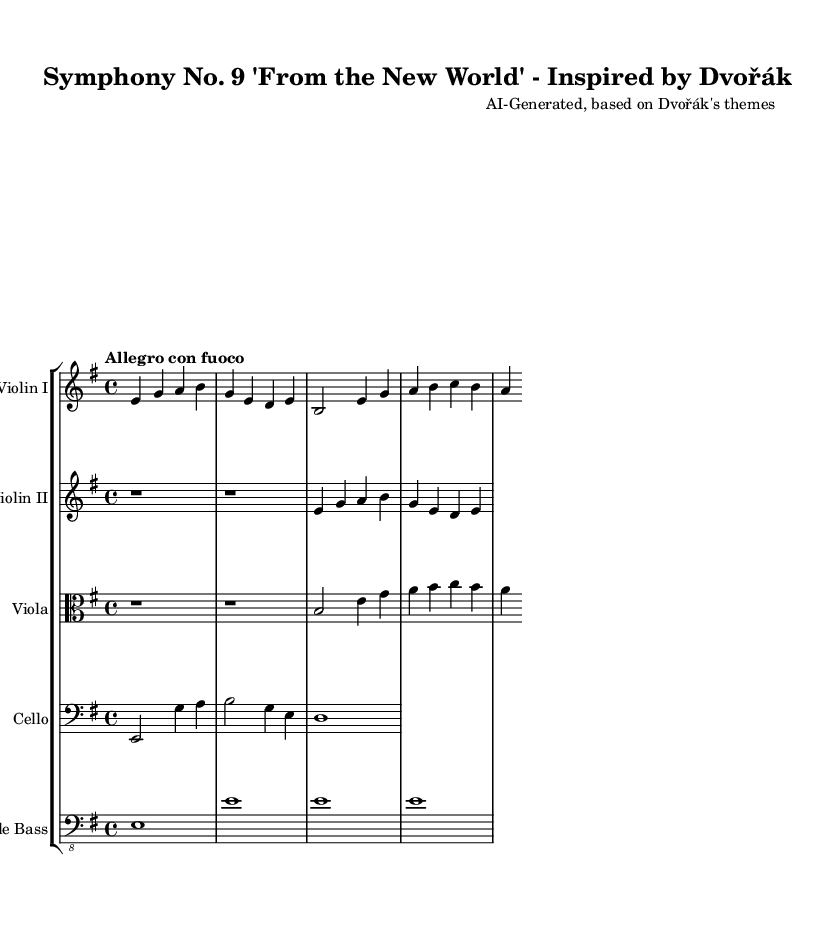What is the key signature of this music? The key signature is E minor, which has one sharp (F#).
Answer: E minor What is the time signature of this music? The time signature shown at the beginning of the score is 4/4, indicating four beats per measure.
Answer: 4/4 What is the tempo marking for this piece? The tempo marking is "Allegro con fuoco," suggesting a fast pace with fiery intensity.
Answer: Allegro con fuoco How many themes are presented in the strings? There are two main themes presented: the main theme and the secondary theme.
Answer: Two Which instrument plays the main theme first? The main theme is first played by the Violin I.
Answer: Violin I What is the designation for the lowest string instrument present? The lowest string instrument in the score is the Double Bass.
Answer: Double Bass How is the main theme characterized in terms of note values? The main theme is characterized by quarter notes primarily, showcasing a lively rhythmic flow.
Answer: Quarter notes 